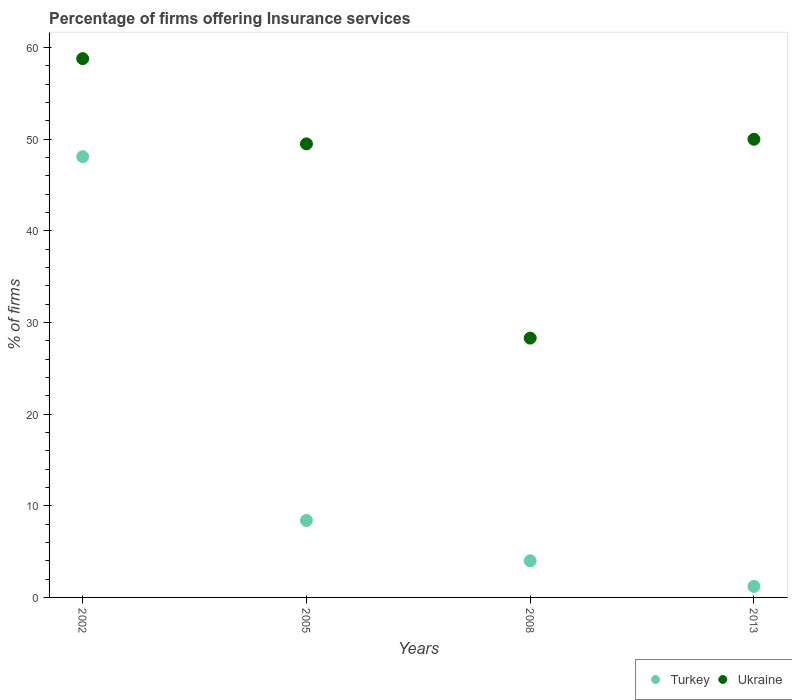What is the percentage of firms offering insurance services in Ukraine in 2008?
Offer a terse response. 28.3. Across all years, what is the maximum percentage of firms offering insurance services in Turkey?
Your answer should be very brief. 48.1. In which year was the percentage of firms offering insurance services in Ukraine maximum?
Your response must be concise. 2002. What is the total percentage of firms offering insurance services in Turkey in the graph?
Offer a very short reply. 61.7. What is the difference between the percentage of firms offering insurance services in Turkey in 2002 and that in 2008?
Ensure brevity in your answer.  44.1. What is the difference between the percentage of firms offering insurance services in Turkey in 2002 and the percentage of firms offering insurance services in Ukraine in 2013?
Your answer should be very brief. -1.9. What is the average percentage of firms offering insurance services in Turkey per year?
Make the answer very short. 15.43. In the year 2002, what is the difference between the percentage of firms offering insurance services in Ukraine and percentage of firms offering insurance services in Turkey?
Give a very brief answer. 10.7. Is the percentage of firms offering insurance services in Ukraine in 2005 less than that in 2008?
Keep it short and to the point. No. Is the difference between the percentage of firms offering insurance services in Ukraine in 2002 and 2013 greater than the difference between the percentage of firms offering insurance services in Turkey in 2002 and 2013?
Your answer should be compact. No. What is the difference between the highest and the second highest percentage of firms offering insurance services in Ukraine?
Give a very brief answer. 8.8. What is the difference between the highest and the lowest percentage of firms offering insurance services in Ukraine?
Ensure brevity in your answer.  30.5. Is the sum of the percentage of firms offering insurance services in Ukraine in 2002 and 2008 greater than the maximum percentage of firms offering insurance services in Turkey across all years?
Ensure brevity in your answer.  Yes. Does the percentage of firms offering insurance services in Turkey monotonically increase over the years?
Your response must be concise. No. Is the percentage of firms offering insurance services in Ukraine strictly greater than the percentage of firms offering insurance services in Turkey over the years?
Offer a terse response. Yes. Is the percentage of firms offering insurance services in Turkey strictly less than the percentage of firms offering insurance services in Ukraine over the years?
Provide a short and direct response. Yes. How many years are there in the graph?
Offer a very short reply. 4. What is the difference between two consecutive major ticks on the Y-axis?
Give a very brief answer. 10. Does the graph contain any zero values?
Your answer should be very brief. No. Does the graph contain grids?
Offer a terse response. No. How are the legend labels stacked?
Give a very brief answer. Horizontal. What is the title of the graph?
Ensure brevity in your answer.  Percentage of firms offering Insurance services. What is the label or title of the X-axis?
Provide a short and direct response. Years. What is the label or title of the Y-axis?
Your response must be concise. % of firms. What is the % of firms in Turkey in 2002?
Offer a very short reply. 48.1. What is the % of firms of Ukraine in 2002?
Give a very brief answer. 58.8. What is the % of firms in Ukraine in 2005?
Make the answer very short. 49.5. What is the % of firms of Turkey in 2008?
Make the answer very short. 4. What is the % of firms in Ukraine in 2008?
Ensure brevity in your answer.  28.3. Across all years, what is the maximum % of firms of Turkey?
Provide a short and direct response. 48.1. Across all years, what is the maximum % of firms of Ukraine?
Your response must be concise. 58.8. Across all years, what is the minimum % of firms of Turkey?
Give a very brief answer. 1.2. Across all years, what is the minimum % of firms in Ukraine?
Your response must be concise. 28.3. What is the total % of firms in Turkey in the graph?
Provide a succinct answer. 61.7. What is the total % of firms of Ukraine in the graph?
Offer a terse response. 186.6. What is the difference between the % of firms of Turkey in 2002 and that in 2005?
Provide a short and direct response. 39.7. What is the difference between the % of firms in Ukraine in 2002 and that in 2005?
Ensure brevity in your answer.  9.3. What is the difference between the % of firms of Turkey in 2002 and that in 2008?
Ensure brevity in your answer.  44.1. What is the difference between the % of firms in Ukraine in 2002 and that in 2008?
Offer a terse response. 30.5. What is the difference between the % of firms of Turkey in 2002 and that in 2013?
Your answer should be very brief. 46.9. What is the difference between the % of firms in Turkey in 2005 and that in 2008?
Provide a short and direct response. 4.4. What is the difference between the % of firms of Ukraine in 2005 and that in 2008?
Offer a very short reply. 21.2. What is the difference between the % of firms of Turkey in 2008 and that in 2013?
Your answer should be compact. 2.8. What is the difference between the % of firms of Ukraine in 2008 and that in 2013?
Your answer should be compact. -21.7. What is the difference between the % of firms of Turkey in 2002 and the % of firms of Ukraine in 2005?
Make the answer very short. -1.4. What is the difference between the % of firms in Turkey in 2002 and the % of firms in Ukraine in 2008?
Provide a succinct answer. 19.8. What is the difference between the % of firms of Turkey in 2005 and the % of firms of Ukraine in 2008?
Your answer should be compact. -19.9. What is the difference between the % of firms in Turkey in 2005 and the % of firms in Ukraine in 2013?
Keep it short and to the point. -41.6. What is the difference between the % of firms in Turkey in 2008 and the % of firms in Ukraine in 2013?
Your answer should be compact. -46. What is the average % of firms of Turkey per year?
Offer a terse response. 15.43. What is the average % of firms in Ukraine per year?
Make the answer very short. 46.65. In the year 2002, what is the difference between the % of firms of Turkey and % of firms of Ukraine?
Provide a short and direct response. -10.7. In the year 2005, what is the difference between the % of firms in Turkey and % of firms in Ukraine?
Ensure brevity in your answer.  -41.1. In the year 2008, what is the difference between the % of firms in Turkey and % of firms in Ukraine?
Provide a succinct answer. -24.3. In the year 2013, what is the difference between the % of firms of Turkey and % of firms of Ukraine?
Provide a short and direct response. -48.8. What is the ratio of the % of firms of Turkey in 2002 to that in 2005?
Make the answer very short. 5.73. What is the ratio of the % of firms in Ukraine in 2002 to that in 2005?
Offer a very short reply. 1.19. What is the ratio of the % of firms in Turkey in 2002 to that in 2008?
Your answer should be very brief. 12.03. What is the ratio of the % of firms of Ukraine in 2002 to that in 2008?
Ensure brevity in your answer.  2.08. What is the ratio of the % of firms in Turkey in 2002 to that in 2013?
Offer a very short reply. 40.08. What is the ratio of the % of firms in Ukraine in 2002 to that in 2013?
Keep it short and to the point. 1.18. What is the ratio of the % of firms in Turkey in 2005 to that in 2008?
Offer a very short reply. 2.1. What is the ratio of the % of firms of Ukraine in 2005 to that in 2008?
Make the answer very short. 1.75. What is the ratio of the % of firms of Ukraine in 2005 to that in 2013?
Your response must be concise. 0.99. What is the ratio of the % of firms of Ukraine in 2008 to that in 2013?
Your answer should be very brief. 0.57. What is the difference between the highest and the second highest % of firms in Turkey?
Provide a short and direct response. 39.7. What is the difference between the highest and the lowest % of firms of Turkey?
Your answer should be very brief. 46.9. What is the difference between the highest and the lowest % of firms in Ukraine?
Offer a very short reply. 30.5. 